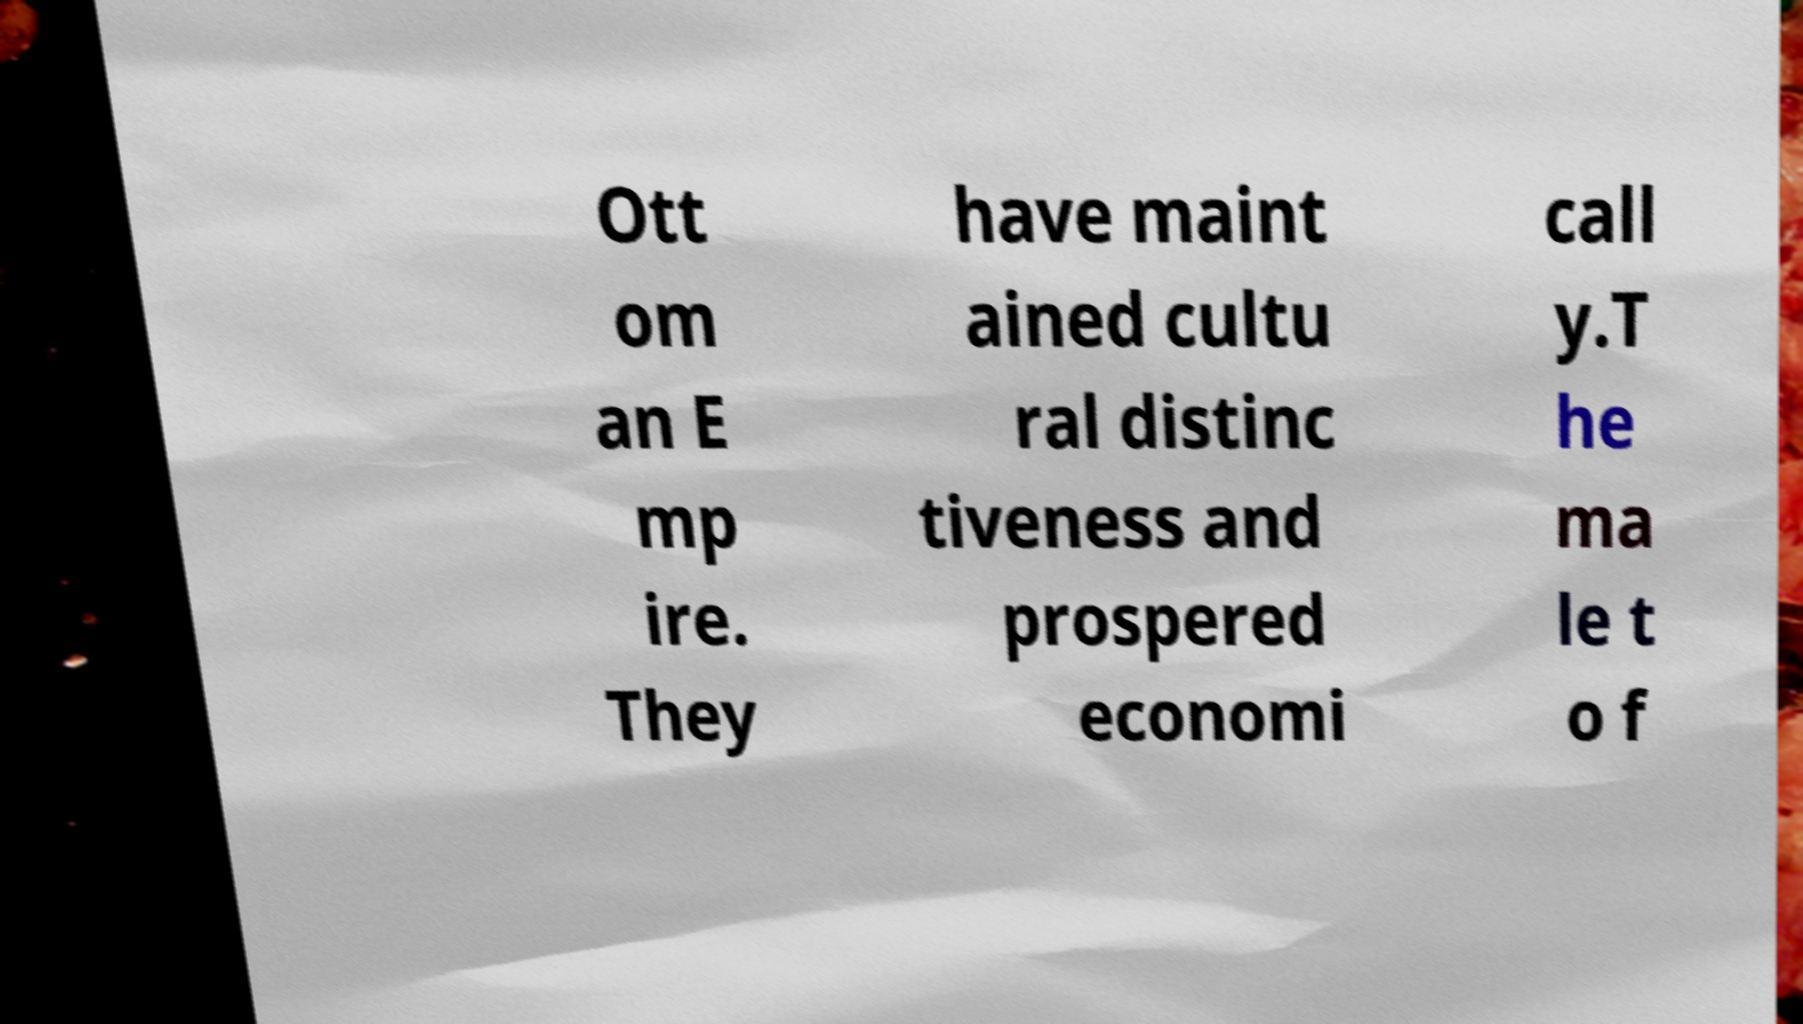For documentation purposes, I need the text within this image transcribed. Could you provide that? Ott om an E mp ire. They have maint ained cultu ral distinc tiveness and prospered economi call y.T he ma le t o f 